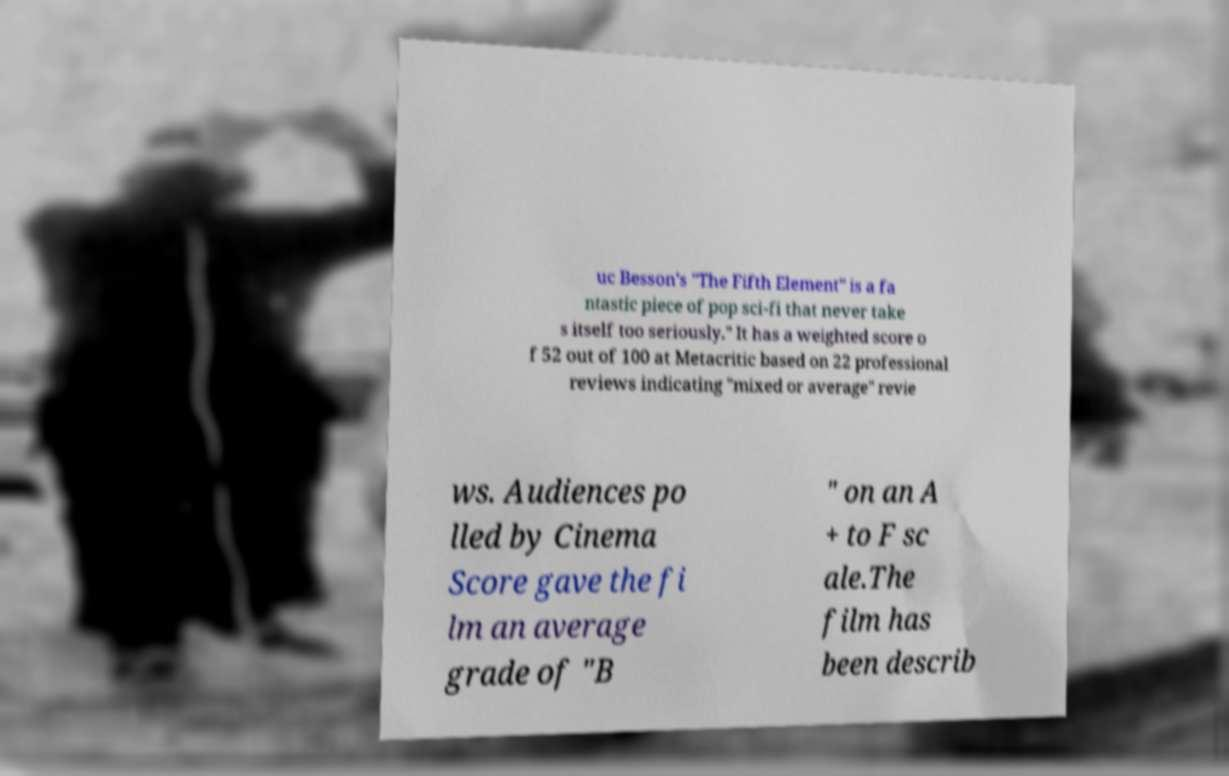For documentation purposes, I need the text within this image transcribed. Could you provide that? uc Besson's "The Fifth Element" is a fa ntastic piece of pop sci-fi that never take s itself too seriously." It has a weighted score o f 52 out of 100 at Metacritic based on 22 professional reviews indicating "mixed or average" revie ws. Audiences po lled by Cinema Score gave the fi lm an average grade of "B " on an A + to F sc ale.The film has been describ 